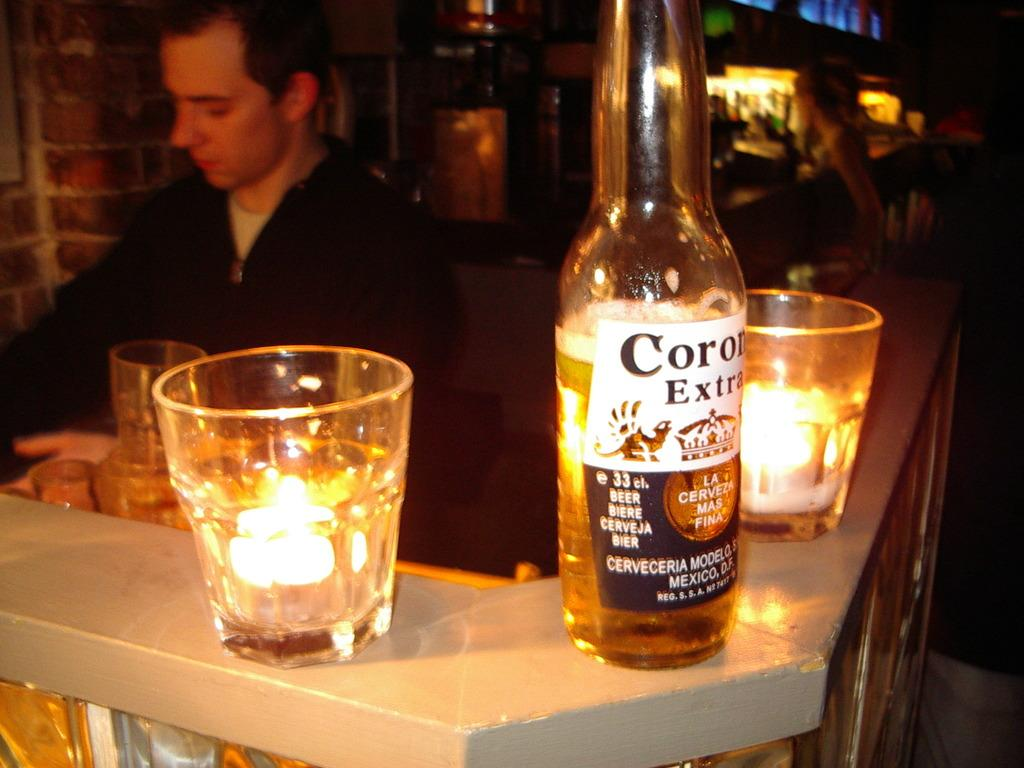Who is present in the image? There is a man in the image. What is the man wearing? The man is wearing a black jacket. What type of object can be seen in the image? There is a glass bottle in the image. What else can be seen in the image that might be used for drinking? There are glasses in the image. What type of lace can be seen on the man's jacket in the image? There is no lace visible on the man's jacket in the image; it is a black jacket with no visible lace. 